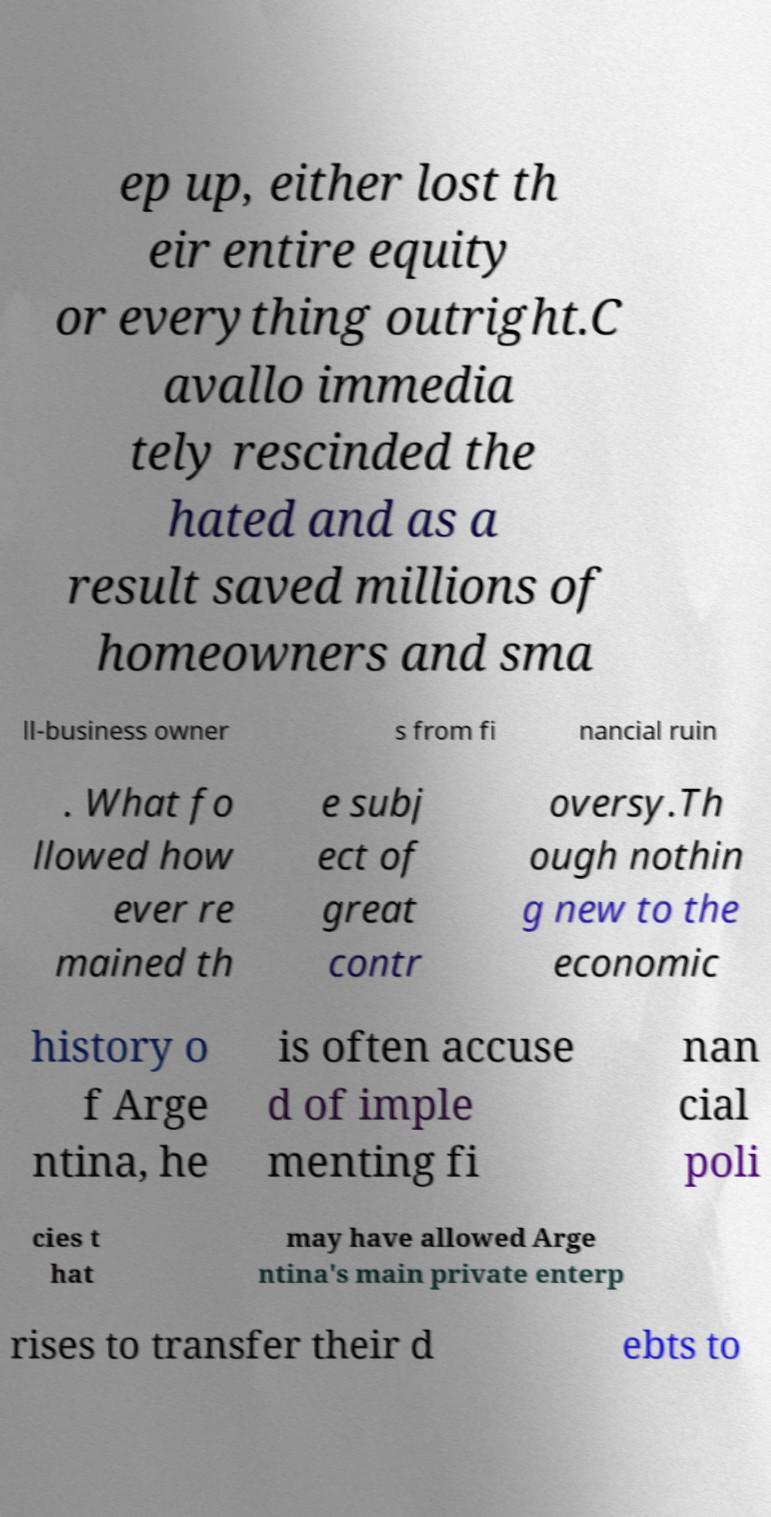Could you assist in decoding the text presented in this image and type it out clearly? ep up, either lost th eir entire equity or everything outright.C avallo immedia tely rescinded the hated and as a result saved millions of homeowners and sma ll-business owner s from fi nancial ruin . What fo llowed how ever re mained th e subj ect of great contr oversy.Th ough nothin g new to the economic history o f Arge ntina, he is often accuse d of imple menting fi nan cial poli cies t hat may have allowed Arge ntina's main private enterp rises to transfer their d ebts to 